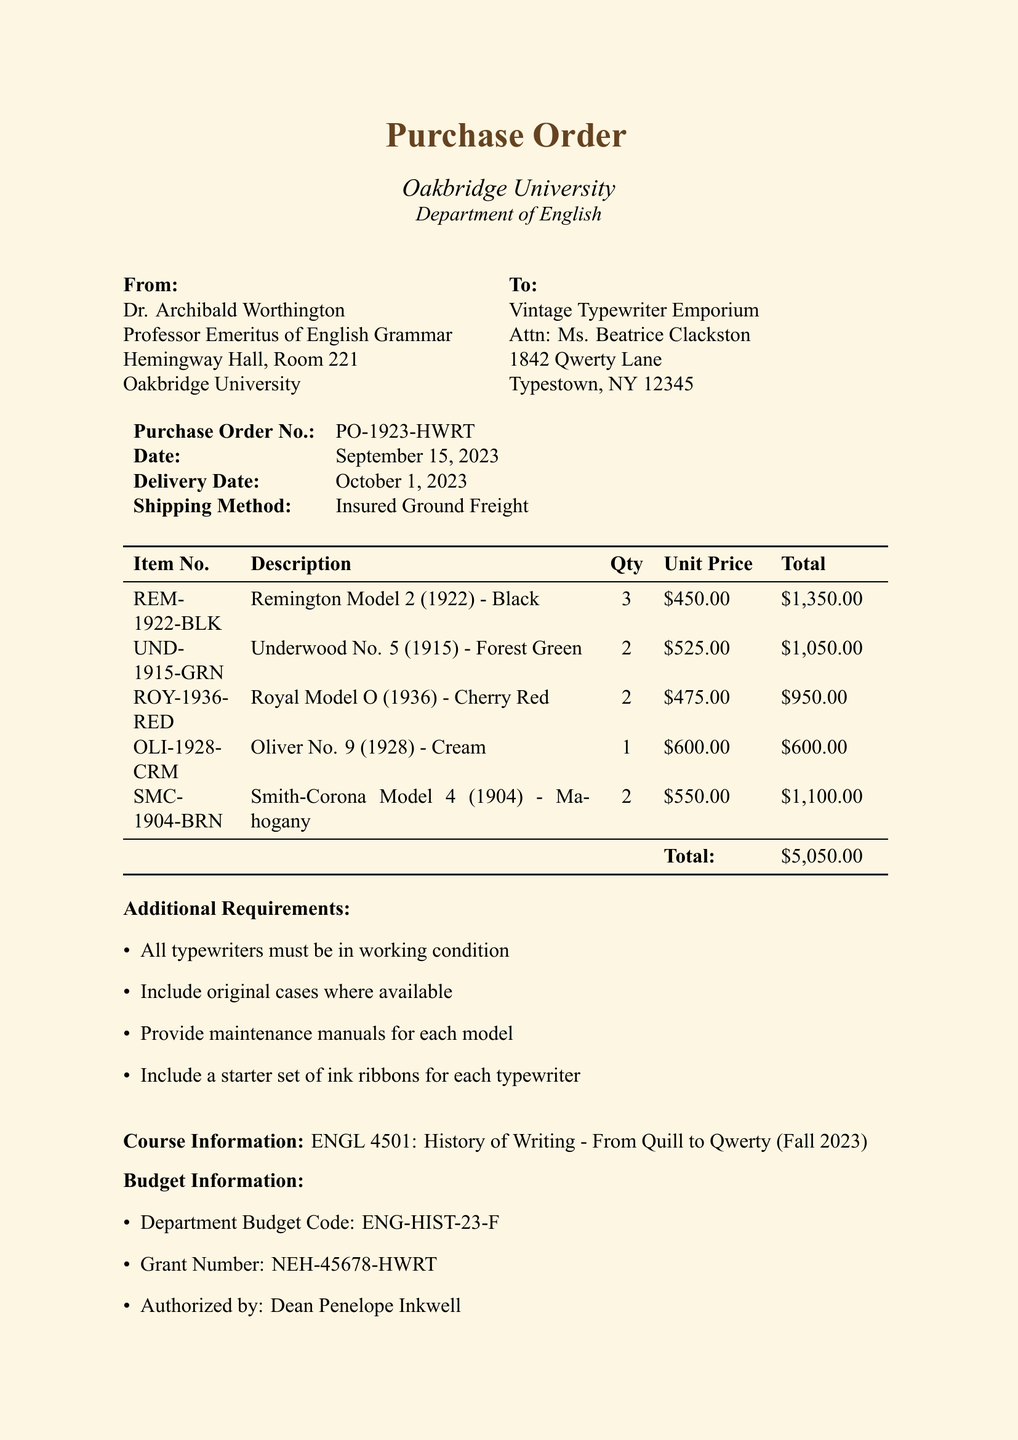What is the name of the professor placing the order? The document states that the order is placed by Dr. Archibald Worthington.
Answer: Dr. Archibald Worthington What is the purchase order number? The purchase order number is specified in the order details section as PO-1923-HWRT.
Answer: PO-1923-HWRT How many Underwood No. 5 typewriters are ordered? According to the item list, there are 2 Underwood No. 5 typewriters ordered.
Answer: 2 What is the total cost of all typewriters? The total cost is presented at the bottom of the itemized list, amounting to $5,050.00.
Answer: $5,050.00 When is the expected delivery date? The delivery date is indicated in the order details section as October 1, 2023.
Answer: October 1, 2023 What shipping method is specified for this order? The shipping method is detailed in the order information and is listed as Insured Ground Freight.
Answer: Insured Ground Freight Who authorized the budget for this purchase? The authorized person is specified in the budget information as Dean Penelope Inkwell.
Answer: Dean Penelope Inkwell What is one of the additional requirements for the typewriters? The additional requirements include that all typewriters must be in working condition.
Answer: All typewriters must be in working condition 